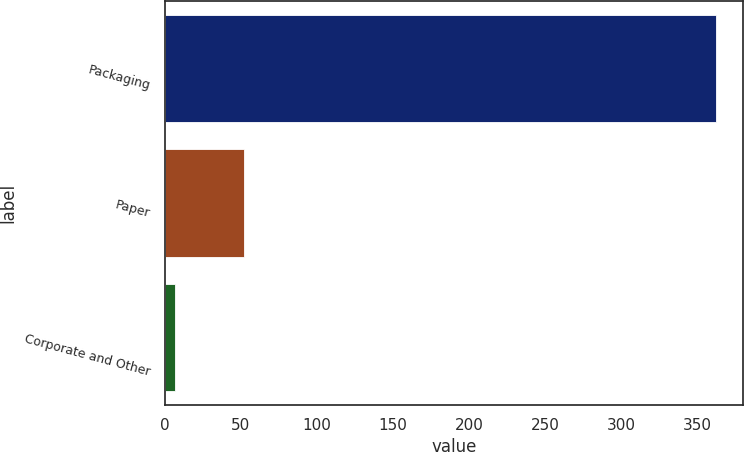<chart> <loc_0><loc_0><loc_500><loc_500><bar_chart><fcel>Packaging<fcel>Paper<fcel>Corporate and Other<nl><fcel>362.1<fcel>51.7<fcel>6.4<nl></chart> 